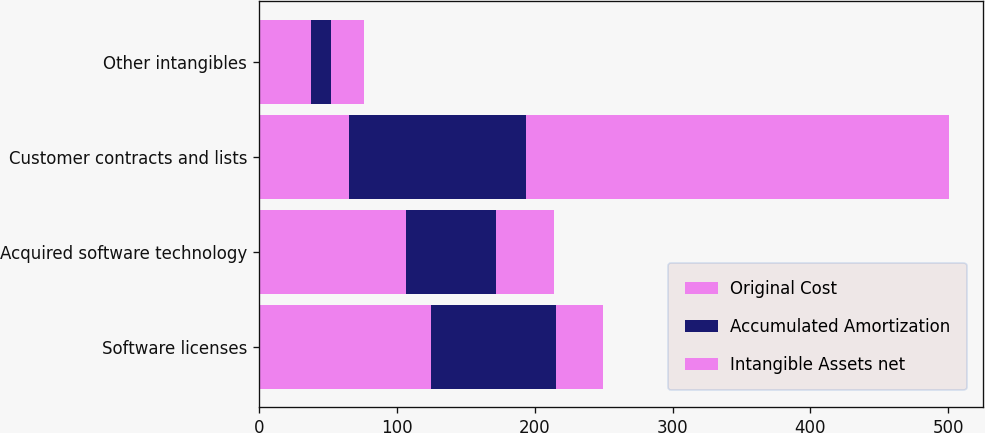<chart> <loc_0><loc_0><loc_500><loc_500><stacked_bar_chart><ecel><fcel>Software licenses<fcel>Acquired software technology<fcel>Customer contracts and lists<fcel>Other intangibles<nl><fcel>Original Cost<fcel>124.6<fcel>106.9<fcel>65.1<fcel>38.1<nl><fcel>Accumulated Amortization<fcel>91.1<fcel>65.1<fcel>128.3<fcel>14.2<nl><fcel>Intangible Assets net<fcel>33.6<fcel>41.9<fcel>307<fcel>24<nl></chart> 